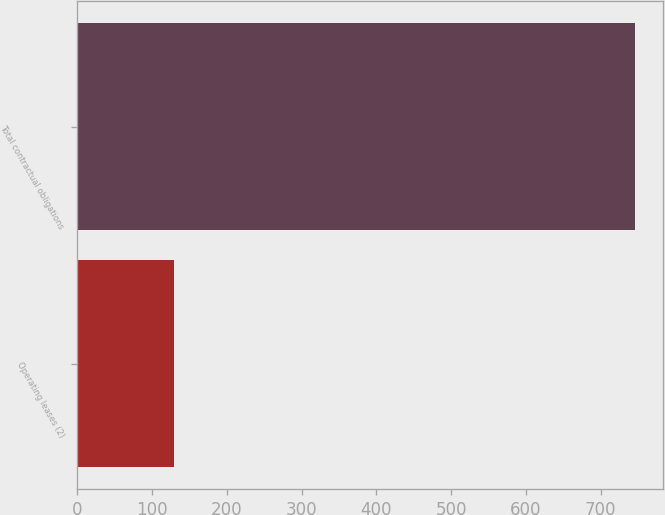Convert chart. <chart><loc_0><loc_0><loc_500><loc_500><bar_chart><fcel>Operating leases (2)<fcel>Total contractual obligations<nl><fcel>130<fcel>746<nl></chart> 